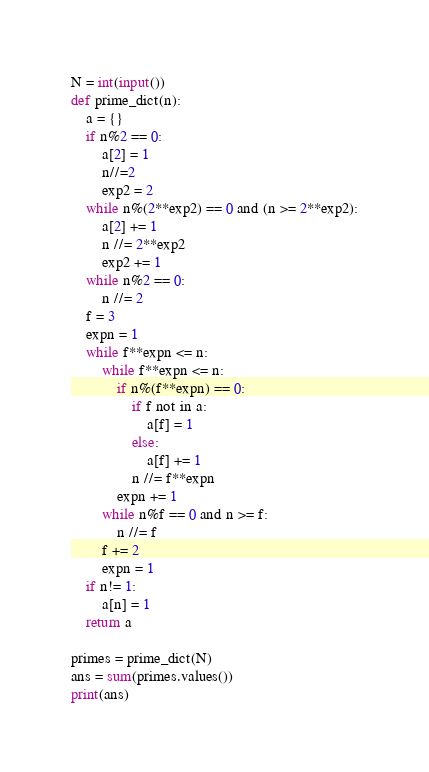<code> <loc_0><loc_0><loc_500><loc_500><_Python_>N = int(input())
def prime_dict(n):
    a = {}
    if n%2 == 0:
        a[2] = 1
        n//=2
        exp2 = 2
    while n%(2**exp2) == 0 and (n >= 2**exp2):
        a[2] += 1
        n //= 2**exp2
        exp2 += 1
    while n%2 == 0:
        n //= 2
    f = 3
    expn = 1
    while f**expn <= n:
        while f**expn <= n:
            if n%(f**expn) == 0:
                if f not in a:
                    a[f] = 1
                else:
                    a[f] += 1
                n //= f**expn
            expn += 1
        while n%f == 0 and n >= f:
            n //= f
        f += 2
        expn = 1
    if n!= 1:
        a[n] = 1
    return a

primes = prime_dict(N)
ans = sum(primes.values())
print(ans)

</code> 